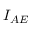<formula> <loc_0><loc_0><loc_500><loc_500>I _ { A E }</formula> 